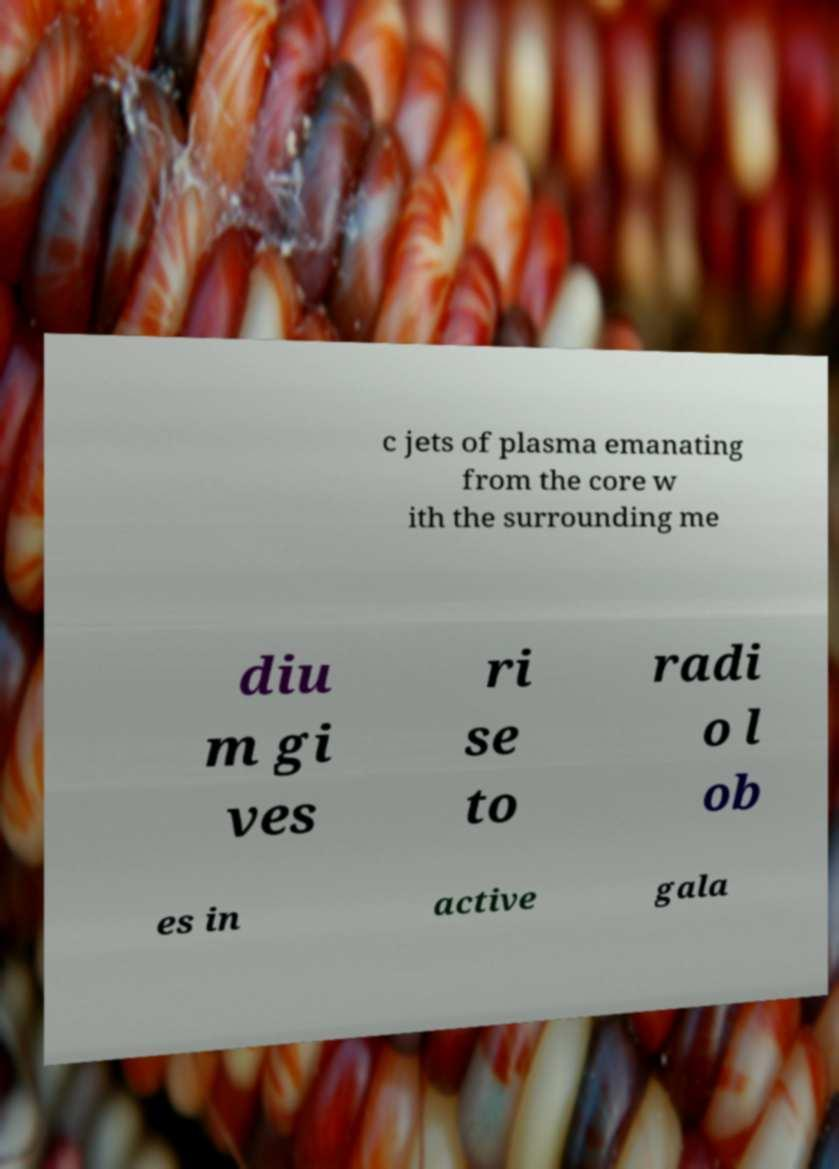Can you read and provide the text displayed in the image?This photo seems to have some interesting text. Can you extract and type it out for me? c jets of plasma emanating from the core w ith the surrounding me diu m gi ves ri se to radi o l ob es in active gala 